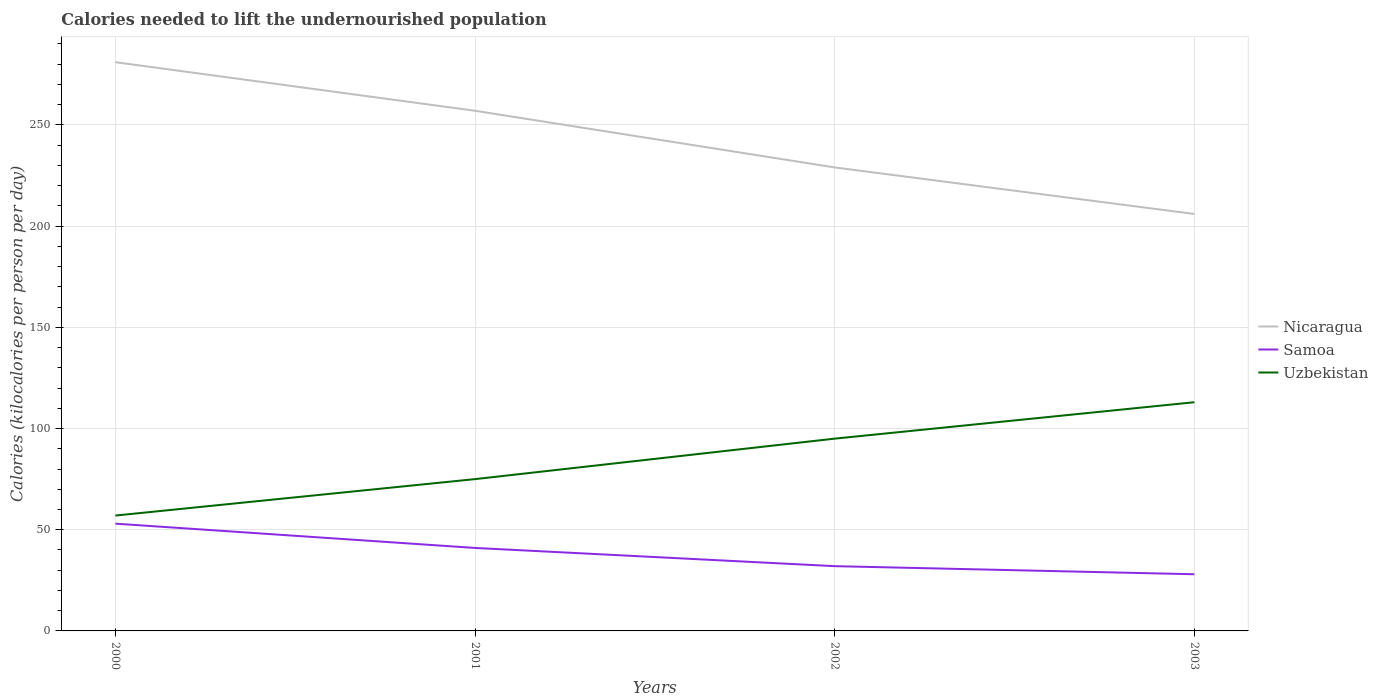How many different coloured lines are there?
Your answer should be compact. 3. Is the number of lines equal to the number of legend labels?
Provide a short and direct response. Yes. Across all years, what is the maximum total calories needed to lift the undernourished population in Uzbekistan?
Your response must be concise. 57. In which year was the total calories needed to lift the undernourished population in Samoa maximum?
Your response must be concise. 2003. What is the total total calories needed to lift the undernourished population in Nicaragua in the graph?
Your answer should be very brief. 75. What is the difference between the highest and the second highest total calories needed to lift the undernourished population in Samoa?
Give a very brief answer. 25. Is the total calories needed to lift the undernourished population in Uzbekistan strictly greater than the total calories needed to lift the undernourished population in Samoa over the years?
Your answer should be compact. No. How many years are there in the graph?
Your answer should be compact. 4. Are the values on the major ticks of Y-axis written in scientific E-notation?
Keep it short and to the point. No. Does the graph contain grids?
Make the answer very short. Yes. How many legend labels are there?
Offer a terse response. 3. What is the title of the graph?
Provide a short and direct response. Calories needed to lift the undernourished population. Does "Seychelles" appear as one of the legend labels in the graph?
Ensure brevity in your answer.  No. What is the label or title of the Y-axis?
Your answer should be compact. Calories (kilocalories per person per day). What is the Calories (kilocalories per person per day) in Nicaragua in 2000?
Make the answer very short. 281. What is the Calories (kilocalories per person per day) of Samoa in 2000?
Offer a terse response. 53. What is the Calories (kilocalories per person per day) of Uzbekistan in 2000?
Make the answer very short. 57. What is the Calories (kilocalories per person per day) in Nicaragua in 2001?
Ensure brevity in your answer.  257. What is the Calories (kilocalories per person per day) of Uzbekistan in 2001?
Provide a short and direct response. 75. What is the Calories (kilocalories per person per day) in Nicaragua in 2002?
Provide a succinct answer. 229. What is the Calories (kilocalories per person per day) of Samoa in 2002?
Ensure brevity in your answer.  32. What is the Calories (kilocalories per person per day) in Uzbekistan in 2002?
Your answer should be very brief. 95. What is the Calories (kilocalories per person per day) of Nicaragua in 2003?
Provide a short and direct response. 206. What is the Calories (kilocalories per person per day) of Samoa in 2003?
Provide a short and direct response. 28. What is the Calories (kilocalories per person per day) in Uzbekistan in 2003?
Provide a short and direct response. 113. Across all years, what is the maximum Calories (kilocalories per person per day) of Nicaragua?
Your response must be concise. 281. Across all years, what is the maximum Calories (kilocalories per person per day) in Samoa?
Offer a terse response. 53. Across all years, what is the maximum Calories (kilocalories per person per day) in Uzbekistan?
Ensure brevity in your answer.  113. Across all years, what is the minimum Calories (kilocalories per person per day) of Nicaragua?
Ensure brevity in your answer.  206. What is the total Calories (kilocalories per person per day) in Nicaragua in the graph?
Give a very brief answer. 973. What is the total Calories (kilocalories per person per day) of Samoa in the graph?
Offer a terse response. 154. What is the total Calories (kilocalories per person per day) in Uzbekistan in the graph?
Your answer should be very brief. 340. What is the difference between the Calories (kilocalories per person per day) in Nicaragua in 2000 and that in 2001?
Give a very brief answer. 24. What is the difference between the Calories (kilocalories per person per day) of Nicaragua in 2000 and that in 2002?
Offer a very short reply. 52. What is the difference between the Calories (kilocalories per person per day) in Uzbekistan in 2000 and that in 2002?
Your response must be concise. -38. What is the difference between the Calories (kilocalories per person per day) in Nicaragua in 2000 and that in 2003?
Provide a succinct answer. 75. What is the difference between the Calories (kilocalories per person per day) of Samoa in 2000 and that in 2003?
Make the answer very short. 25. What is the difference between the Calories (kilocalories per person per day) in Uzbekistan in 2000 and that in 2003?
Offer a very short reply. -56. What is the difference between the Calories (kilocalories per person per day) of Samoa in 2001 and that in 2002?
Make the answer very short. 9. What is the difference between the Calories (kilocalories per person per day) in Uzbekistan in 2001 and that in 2002?
Your answer should be very brief. -20. What is the difference between the Calories (kilocalories per person per day) of Nicaragua in 2001 and that in 2003?
Make the answer very short. 51. What is the difference between the Calories (kilocalories per person per day) in Samoa in 2001 and that in 2003?
Your answer should be compact. 13. What is the difference between the Calories (kilocalories per person per day) of Uzbekistan in 2001 and that in 2003?
Your answer should be compact. -38. What is the difference between the Calories (kilocalories per person per day) in Samoa in 2002 and that in 2003?
Make the answer very short. 4. What is the difference between the Calories (kilocalories per person per day) of Uzbekistan in 2002 and that in 2003?
Make the answer very short. -18. What is the difference between the Calories (kilocalories per person per day) in Nicaragua in 2000 and the Calories (kilocalories per person per day) in Samoa in 2001?
Ensure brevity in your answer.  240. What is the difference between the Calories (kilocalories per person per day) of Nicaragua in 2000 and the Calories (kilocalories per person per day) of Uzbekistan in 2001?
Your response must be concise. 206. What is the difference between the Calories (kilocalories per person per day) in Nicaragua in 2000 and the Calories (kilocalories per person per day) in Samoa in 2002?
Give a very brief answer. 249. What is the difference between the Calories (kilocalories per person per day) in Nicaragua in 2000 and the Calories (kilocalories per person per day) in Uzbekistan in 2002?
Provide a succinct answer. 186. What is the difference between the Calories (kilocalories per person per day) in Samoa in 2000 and the Calories (kilocalories per person per day) in Uzbekistan in 2002?
Offer a very short reply. -42. What is the difference between the Calories (kilocalories per person per day) in Nicaragua in 2000 and the Calories (kilocalories per person per day) in Samoa in 2003?
Your answer should be very brief. 253. What is the difference between the Calories (kilocalories per person per day) in Nicaragua in 2000 and the Calories (kilocalories per person per day) in Uzbekistan in 2003?
Make the answer very short. 168. What is the difference between the Calories (kilocalories per person per day) in Samoa in 2000 and the Calories (kilocalories per person per day) in Uzbekistan in 2003?
Your answer should be very brief. -60. What is the difference between the Calories (kilocalories per person per day) in Nicaragua in 2001 and the Calories (kilocalories per person per day) in Samoa in 2002?
Offer a terse response. 225. What is the difference between the Calories (kilocalories per person per day) of Nicaragua in 2001 and the Calories (kilocalories per person per day) of Uzbekistan in 2002?
Your answer should be very brief. 162. What is the difference between the Calories (kilocalories per person per day) in Samoa in 2001 and the Calories (kilocalories per person per day) in Uzbekistan in 2002?
Offer a very short reply. -54. What is the difference between the Calories (kilocalories per person per day) of Nicaragua in 2001 and the Calories (kilocalories per person per day) of Samoa in 2003?
Your answer should be very brief. 229. What is the difference between the Calories (kilocalories per person per day) of Nicaragua in 2001 and the Calories (kilocalories per person per day) of Uzbekistan in 2003?
Your answer should be very brief. 144. What is the difference between the Calories (kilocalories per person per day) of Samoa in 2001 and the Calories (kilocalories per person per day) of Uzbekistan in 2003?
Ensure brevity in your answer.  -72. What is the difference between the Calories (kilocalories per person per day) in Nicaragua in 2002 and the Calories (kilocalories per person per day) in Samoa in 2003?
Provide a succinct answer. 201. What is the difference between the Calories (kilocalories per person per day) in Nicaragua in 2002 and the Calories (kilocalories per person per day) in Uzbekistan in 2003?
Provide a short and direct response. 116. What is the difference between the Calories (kilocalories per person per day) in Samoa in 2002 and the Calories (kilocalories per person per day) in Uzbekistan in 2003?
Make the answer very short. -81. What is the average Calories (kilocalories per person per day) in Nicaragua per year?
Provide a succinct answer. 243.25. What is the average Calories (kilocalories per person per day) of Samoa per year?
Ensure brevity in your answer.  38.5. In the year 2000, what is the difference between the Calories (kilocalories per person per day) of Nicaragua and Calories (kilocalories per person per day) of Samoa?
Your response must be concise. 228. In the year 2000, what is the difference between the Calories (kilocalories per person per day) of Nicaragua and Calories (kilocalories per person per day) of Uzbekistan?
Ensure brevity in your answer.  224. In the year 2000, what is the difference between the Calories (kilocalories per person per day) of Samoa and Calories (kilocalories per person per day) of Uzbekistan?
Keep it short and to the point. -4. In the year 2001, what is the difference between the Calories (kilocalories per person per day) of Nicaragua and Calories (kilocalories per person per day) of Samoa?
Make the answer very short. 216. In the year 2001, what is the difference between the Calories (kilocalories per person per day) in Nicaragua and Calories (kilocalories per person per day) in Uzbekistan?
Ensure brevity in your answer.  182. In the year 2001, what is the difference between the Calories (kilocalories per person per day) in Samoa and Calories (kilocalories per person per day) in Uzbekistan?
Keep it short and to the point. -34. In the year 2002, what is the difference between the Calories (kilocalories per person per day) of Nicaragua and Calories (kilocalories per person per day) of Samoa?
Offer a very short reply. 197. In the year 2002, what is the difference between the Calories (kilocalories per person per day) of Nicaragua and Calories (kilocalories per person per day) of Uzbekistan?
Your answer should be compact. 134. In the year 2002, what is the difference between the Calories (kilocalories per person per day) in Samoa and Calories (kilocalories per person per day) in Uzbekistan?
Your response must be concise. -63. In the year 2003, what is the difference between the Calories (kilocalories per person per day) of Nicaragua and Calories (kilocalories per person per day) of Samoa?
Your answer should be very brief. 178. In the year 2003, what is the difference between the Calories (kilocalories per person per day) in Nicaragua and Calories (kilocalories per person per day) in Uzbekistan?
Ensure brevity in your answer.  93. In the year 2003, what is the difference between the Calories (kilocalories per person per day) of Samoa and Calories (kilocalories per person per day) of Uzbekistan?
Provide a succinct answer. -85. What is the ratio of the Calories (kilocalories per person per day) of Nicaragua in 2000 to that in 2001?
Give a very brief answer. 1.09. What is the ratio of the Calories (kilocalories per person per day) in Samoa in 2000 to that in 2001?
Give a very brief answer. 1.29. What is the ratio of the Calories (kilocalories per person per day) of Uzbekistan in 2000 to that in 2001?
Keep it short and to the point. 0.76. What is the ratio of the Calories (kilocalories per person per day) in Nicaragua in 2000 to that in 2002?
Your response must be concise. 1.23. What is the ratio of the Calories (kilocalories per person per day) of Samoa in 2000 to that in 2002?
Offer a very short reply. 1.66. What is the ratio of the Calories (kilocalories per person per day) of Uzbekistan in 2000 to that in 2002?
Provide a short and direct response. 0.6. What is the ratio of the Calories (kilocalories per person per day) in Nicaragua in 2000 to that in 2003?
Make the answer very short. 1.36. What is the ratio of the Calories (kilocalories per person per day) in Samoa in 2000 to that in 2003?
Offer a very short reply. 1.89. What is the ratio of the Calories (kilocalories per person per day) in Uzbekistan in 2000 to that in 2003?
Offer a terse response. 0.5. What is the ratio of the Calories (kilocalories per person per day) of Nicaragua in 2001 to that in 2002?
Offer a terse response. 1.12. What is the ratio of the Calories (kilocalories per person per day) of Samoa in 2001 to that in 2002?
Keep it short and to the point. 1.28. What is the ratio of the Calories (kilocalories per person per day) of Uzbekistan in 2001 to that in 2002?
Ensure brevity in your answer.  0.79. What is the ratio of the Calories (kilocalories per person per day) of Nicaragua in 2001 to that in 2003?
Your response must be concise. 1.25. What is the ratio of the Calories (kilocalories per person per day) of Samoa in 2001 to that in 2003?
Give a very brief answer. 1.46. What is the ratio of the Calories (kilocalories per person per day) of Uzbekistan in 2001 to that in 2003?
Keep it short and to the point. 0.66. What is the ratio of the Calories (kilocalories per person per day) of Nicaragua in 2002 to that in 2003?
Give a very brief answer. 1.11. What is the ratio of the Calories (kilocalories per person per day) in Samoa in 2002 to that in 2003?
Ensure brevity in your answer.  1.14. What is the ratio of the Calories (kilocalories per person per day) in Uzbekistan in 2002 to that in 2003?
Give a very brief answer. 0.84. What is the difference between the highest and the second highest Calories (kilocalories per person per day) of Samoa?
Keep it short and to the point. 12. What is the difference between the highest and the second highest Calories (kilocalories per person per day) of Uzbekistan?
Offer a terse response. 18. What is the difference between the highest and the lowest Calories (kilocalories per person per day) in Nicaragua?
Give a very brief answer. 75. What is the difference between the highest and the lowest Calories (kilocalories per person per day) of Samoa?
Your answer should be compact. 25. 